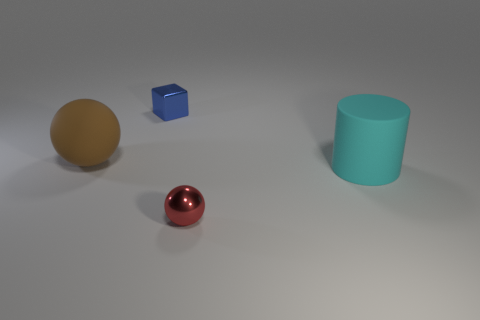Add 1 tiny red metal spheres. How many objects exist? 5 Subtract all yellow balls. Subtract all blue cylinders. How many balls are left? 2 Subtract all cylinders. How many objects are left? 3 Subtract all large brown rubber balls. Subtract all cubes. How many objects are left? 2 Add 1 cylinders. How many cylinders are left? 2 Add 1 tiny blue metal cubes. How many tiny blue metal cubes exist? 2 Subtract 0 cyan blocks. How many objects are left? 4 